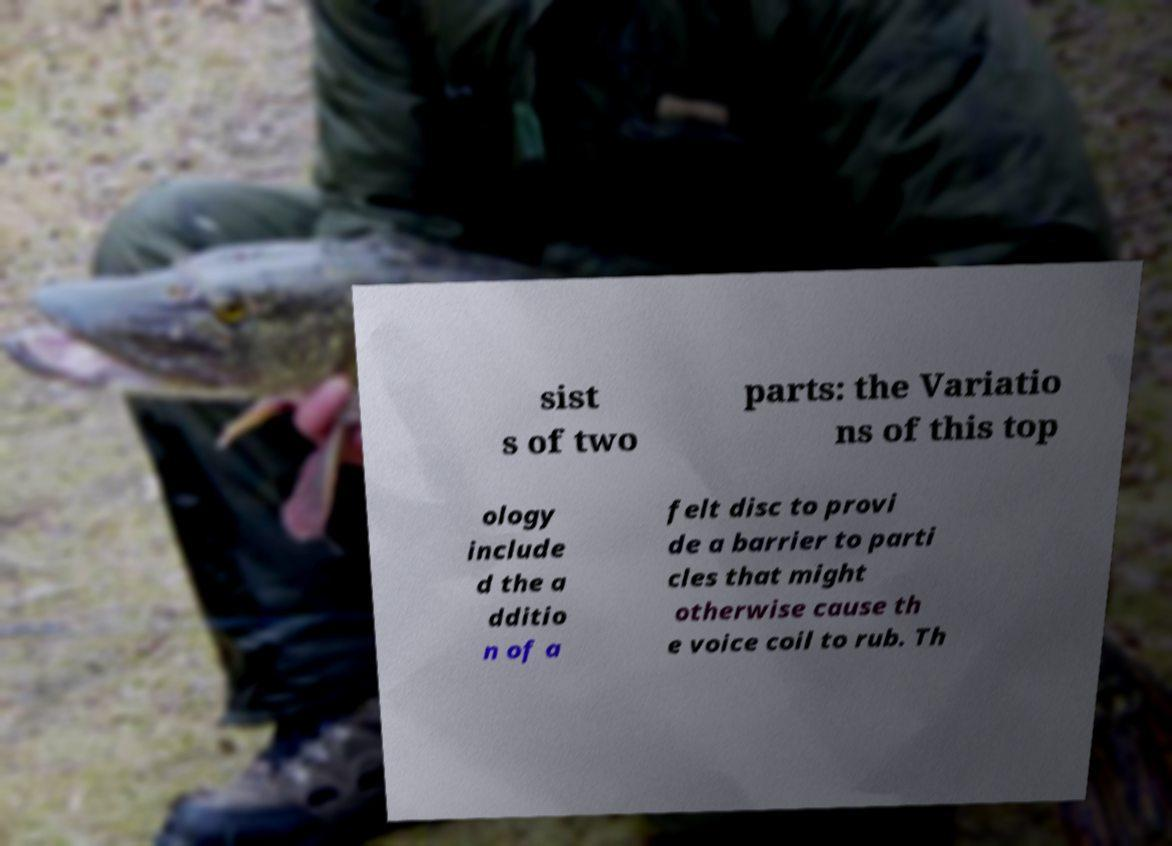Please read and relay the text visible in this image. What does it say? sist s of two parts: the Variatio ns of this top ology include d the a dditio n of a felt disc to provi de a barrier to parti cles that might otherwise cause th e voice coil to rub. Th 